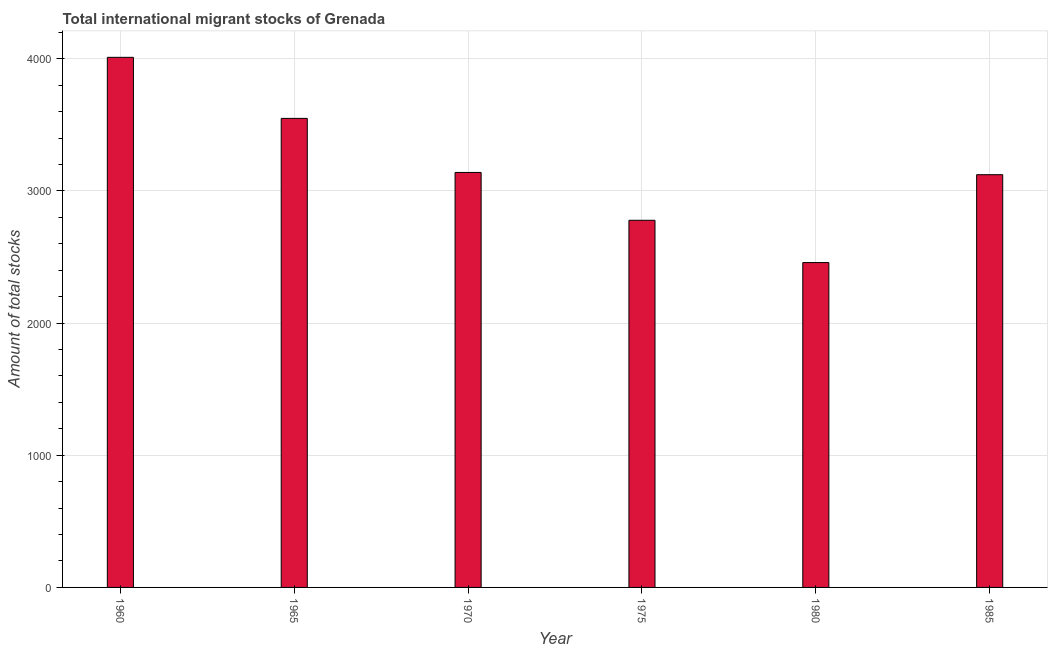Does the graph contain any zero values?
Provide a short and direct response. No. Does the graph contain grids?
Ensure brevity in your answer.  Yes. What is the title of the graph?
Provide a succinct answer. Total international migrant stocks of Grenada. What is the label or title of the X-axis?
Keep it short and to the point. Year. What is the label or title of the Y-axis?
Provide a succinct answer. Amount of total stocks. What is the total number of international migrant stock in 1960?
Your answer should be very brief. 4011. Across all years, what is the maximum total number of international migrant stock?
Offer a very short reply. 4011. Across all years, what is the minimum total number of international migrant stock?
Your answer should be very brief. 2458. What is the sum of the total number of international migrant stock?
Offer a terse response. 1.91e+04. What is the difference between the total number of international migrant stock in 1965 and 1970?
Provide a short and direct response. 409. What is the average total number of international migrant stock per year?
Give a very brief answer. 3176. What is the median total number of international migrant stock?
Keep it short and to the point. 3131.5. In how many years, is the total number of international migrant stock greater than 3400 ?
Offer a very short reply. 2. What is the ratio of the total number of international migrant stock in 1975 to that in 1980?
Offer a terse response. 1.13. Is the difference between the total number of international migrant stock in 1965 and 1985 greater than the difference between any two years?
Offer a terse response. No. What is the difference between the highest and the second highest total number of international migrant stock?
Your response must be concise. 462. What is the difference between the highest and the lowest total number of international migrant stock?
Give a very brief answer. 1553. Are all the bars in the graph horizontal?
Your answer should be very brief. No. What is the Amount of total stocks in 1960?
Ensure brevity in your answer.  4011. What is the Amount of total stocks in 1965?
Your response must be concise. 3549. What is the Amount of total stocks of 1970?
Ensure brevity in your answer.  3140. What is the Amount of total stocks of 1975?
Your answer should be very brief. 2778. What is the Amount of total stocks of 1980?
Make the answer very short. 2458. What is the Amount of total stocks in 1985?
Provide a short and direct response. 3123. What is the difference between the Amount of total stocks in 1960 and 1965?
Offer a very short reply. 462. What is the difference between the Amount of total stocks in 1960 and 1970?
Provide a succinct answer. 871. What is the difference between the Amount of total stocks in 1960 and 1975?
Your response must be concise. 1233. What is the difference between the Amount of total stocks in 1960 and 1980?
Give a very brief answer. 1553. What is the difference between the Amount of total stocks in 1960 and 1985?
Give a very brief answer. 888. What is the difference between the Amount of total stocks in 1965 and 1970?
Provide a succinct answer. 409. What is the difference between the Amount of total stocks in 1965 and 1975?
Keep it short and to the point. 771. What is the difference between the Amount of total stocks in 1965 and 1980?
Offer a terse response. 1091. What is the difference between the Amount of total stocks in 1965 and 1985?
Give a very brief answer. 426. What is the difference between the Amount of total stocks in 1970 and 1975?
Give a very brief answer. 362. What is the difference between the Amount of total stocks in 1970 and 1980?
Offer a terse response. 682. What is the difference between the Amount of total stocks in 1970 and 1985?
Provide a short and direct response. 17. What is the difference between the Amount of total stocks in 1975 and 1980?
Provide a short and direct response. 320. What is the difference between the Amount of total stocks in 1975 and 1985?
Your answer should be compact. -345. What is the difference between the Amount of total stocks in 1980 and 1985?
Provide a succinct answer. -665. What is the ratio of the Amount of total stocks in 1960 to that in 1965?
Your answer should be very brief. 1.13. What is the ratio of the Amount of total stocks in 1960 to that in 1970?
Your answer should be very brief. 1.28. What is the ratio of the Amount of total stocks in 1960 to that in 1975?
Provide a succinct answer. 1.44. What is the ratio of the Amount of total stocks in 1960 to that in 1980?
Offer a very short reply. 1.63. What is the ratio of the Amount of total stocks in 1960 to that in 1985?
Offer a terse response. 1.28. What is the ratio of the Amount of total stocks in 1965 to that in 1970?
Your answer should be compact. 1.13. What is the ratio of the Amount of total stocks in 1965 to that in 1975?
Provide a succinct answer. 1.28. What is the ratio of the Amount of total stocks in 1965 to that in 1980?
Your answer should be compact. 1.44. What is the ratio of the Amount of total stocks in 1965 to that in 1985?
Keep it short and to the point. 1.14. What is the ratio of the Amount of total stocks in 1970 to that in 1975?
Offer a very short reply. 1.13. What is the ratio of the Amount of total stocks in 1970 to that in 1980?
Your answer should be very brief. 1.28. What is the ratio of the Amount of total stocks in 1970 to that in 1985?
Keep it short and to the point. 1. What is the ratio of the Amount of total stocks in 1975 to that in 1980?
Offer a very short reply. 1.13. What is the ratio of the Amount of total stocks in 1975 to that in 1985?
Make the answer very short. 0.89. What is the ratio of the Amount of total stocks in 1980 to that in 1985?
Offer a very short reply. 0.79. 